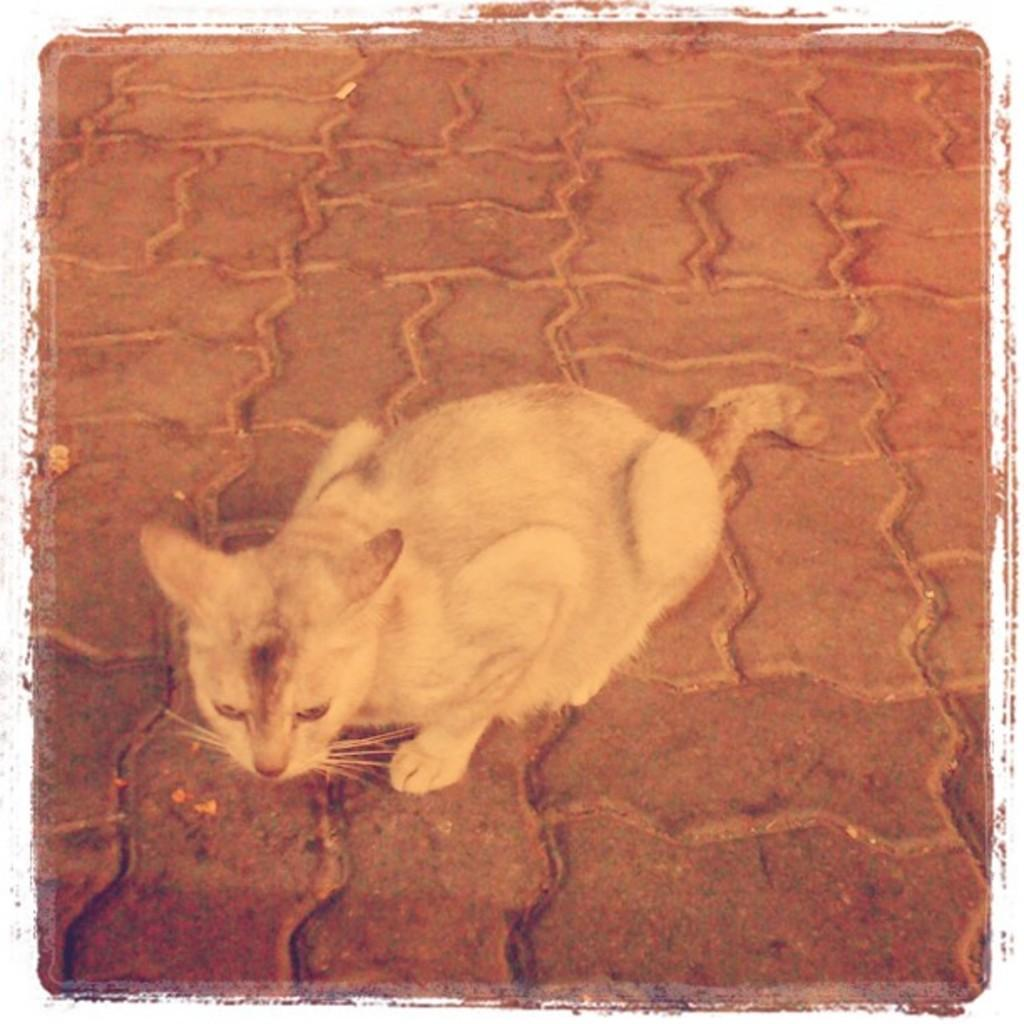What type of animal is in the image? There is a cat in the image. Where is the cat located in the image? The cat is on a path. What type of place is the cat enslaving in the image? There is no indication of any place or enslavement in the image; it simply features a cat on a path. 